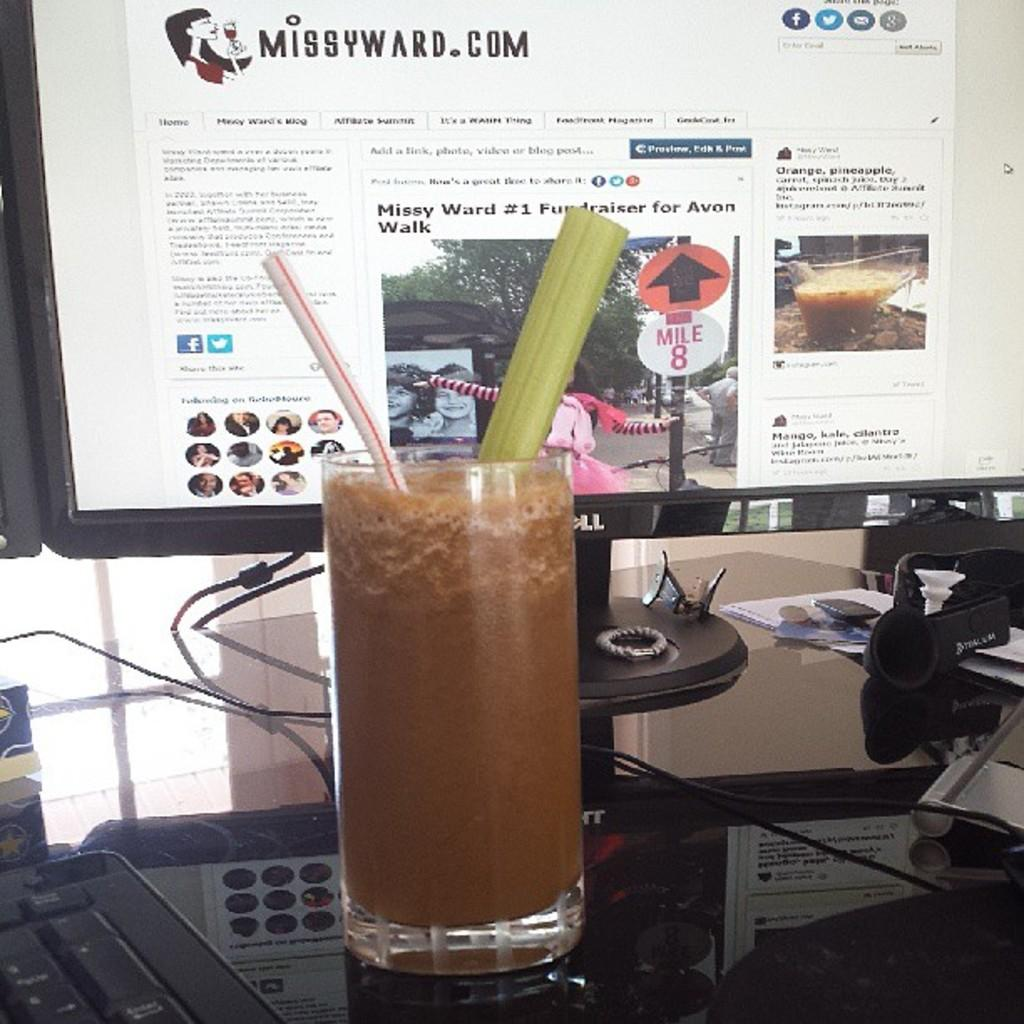What is located on the table in the image? There is a glass on the table in the image. What is in front of the glass on the table? There is a system in front of the glass on the table. What type of crown is placed on the doll in the image? There is no crown or doll present in the image; it only features a glass and a system. 